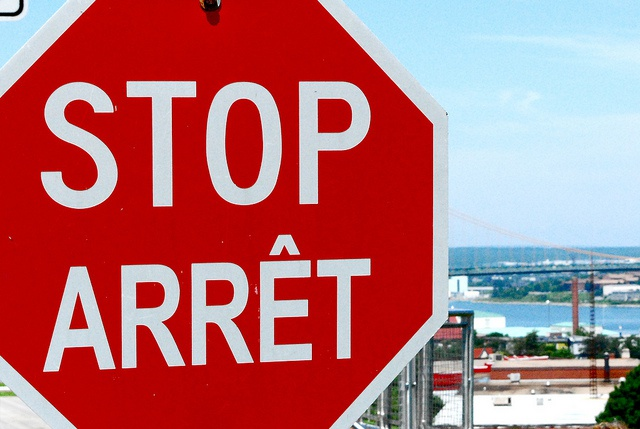Describe the objects in this image and their specific colors. I can see a stop sign in brown, lightgray, and lightpink tones in this image. 